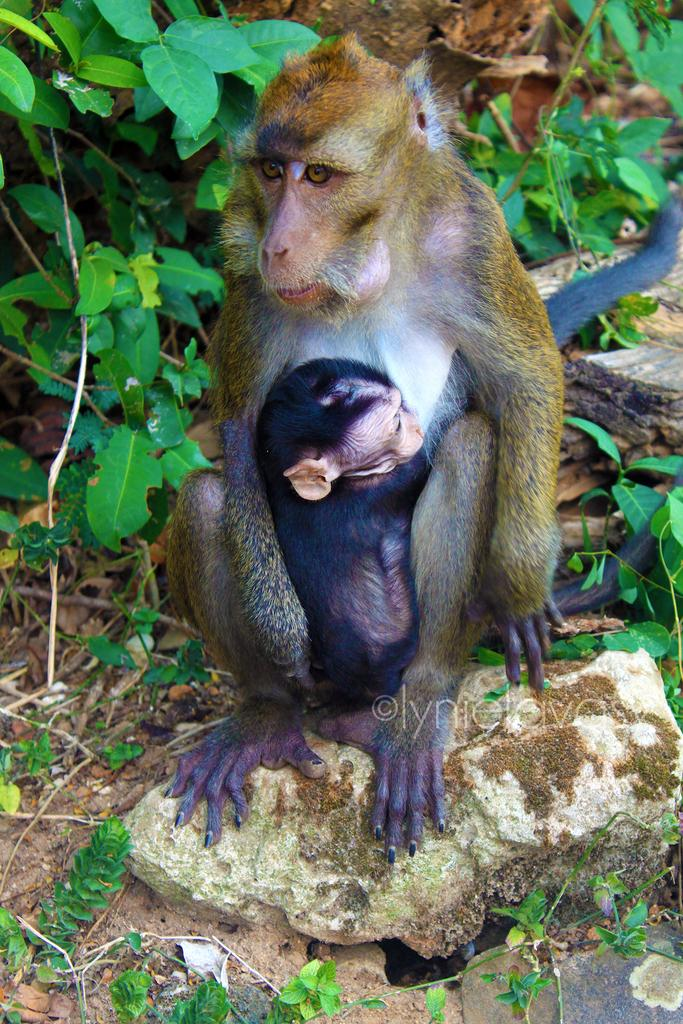What type of animal is in the image? There is a monkey in the image. What other living being is in the image? There is an infant in the image. Where are the monkey and the infant located? Both the monkey and the infant are on a rock. What type of vegetation is visible in the image? There are plants visible in the image. What is the income of the monkey in the image? There is no information about the monkey's income in the image. Can you see a hook attached to the monkey in the image? There is no hook present in the image. 